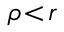<formula> <loc_0><loc_0><loc_500><loc_500>\rho \, < \, r</formula> 